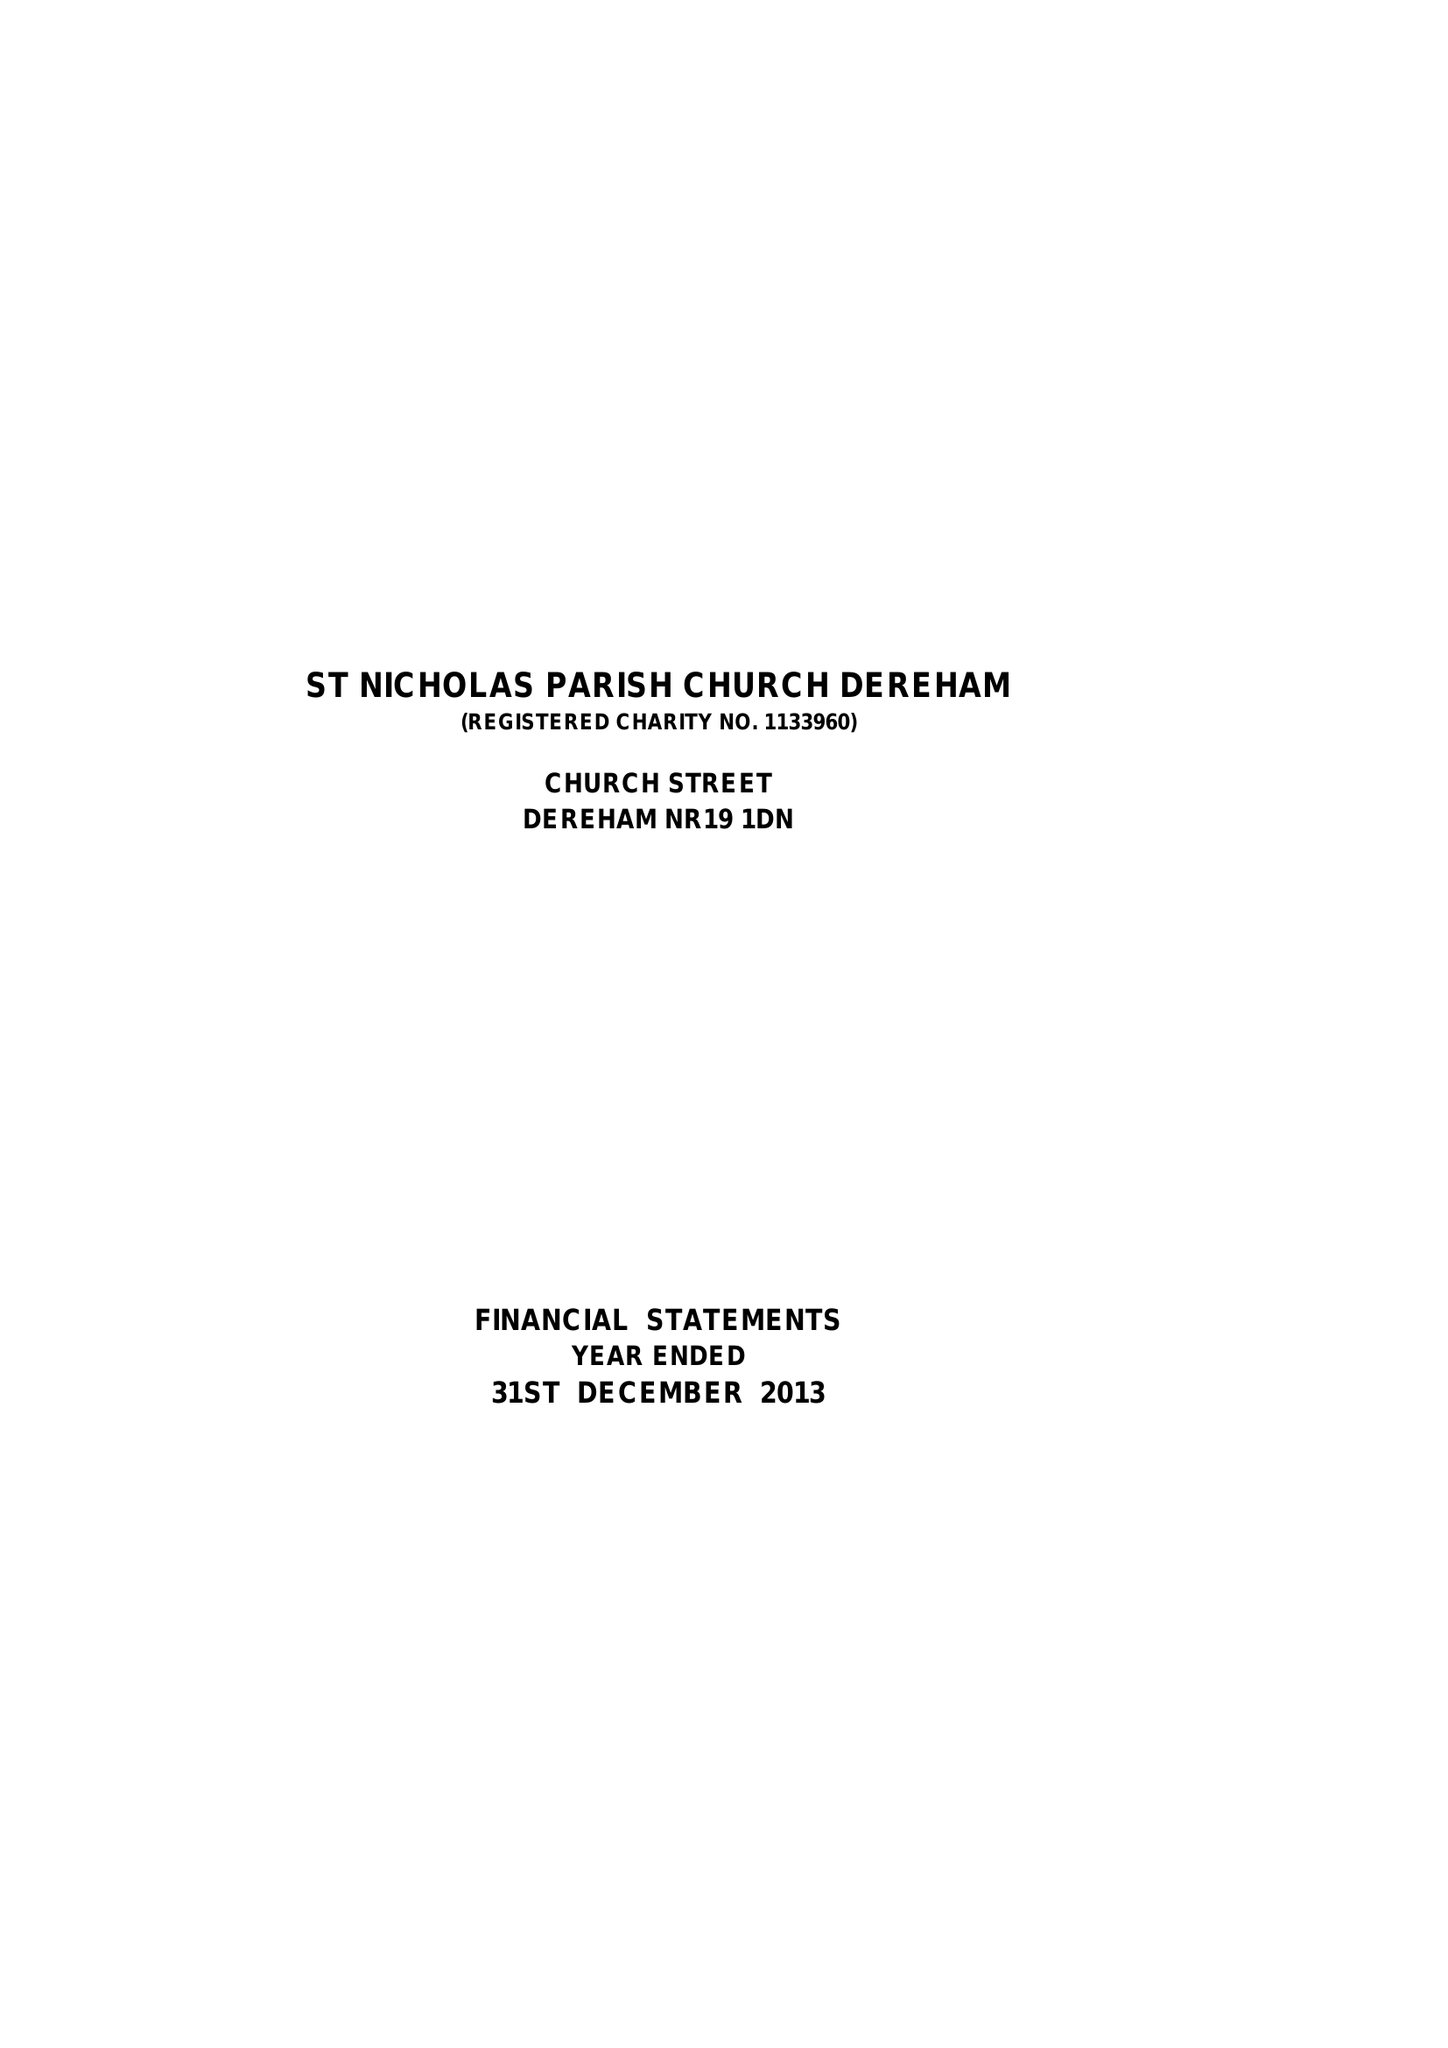What is the value for the address__post_town?
Answer the question using a single word or phrase. DEREHAM 